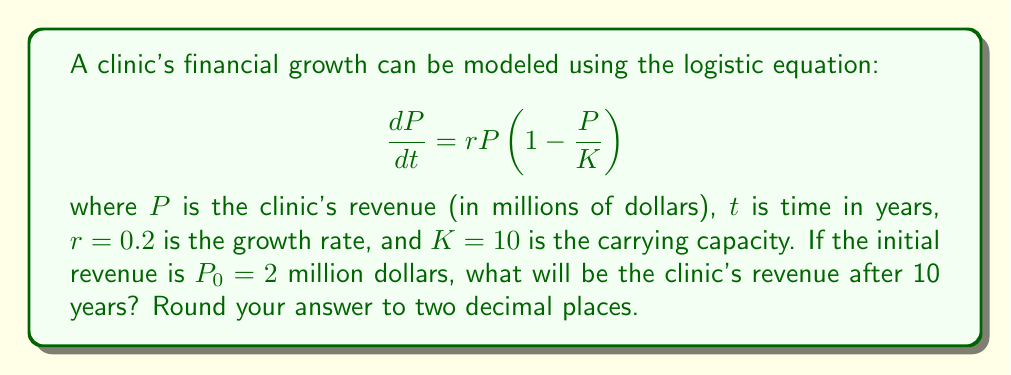Show me your answer to this math problem. To solve this problem, we need to use the solution to the logistic differential equation:

1) The general solution to the logistic equation is:

   $$P(t) = \frac{K}{1 + (\frac{K}{P_0} - 1)e^{-rt}}$$

2) We're given:
   $K = 10$ (carrying capacity)
   $r = 0.2$ (growth rate)
   $P_0 = 2$ (initial revenue)
   $t = 10$ (time in years)

3) Let's substitute these values into the equation:

   $$P(10) = \frac{10}{1 + (\frac{10}{2} - 1)e^{-0.2(10)}}$$

4) Simplify:
   $$P(10) = \frac{10}{1 + 4e^{-2}}$$

5) Calculate $e^{-2} \approx 0.1353$:
   $$P(10) = \frac{10}{1 + 4(0.1353)} = \frac{10}{1.5412}$$

6) Divide:
   $$P(10) \approx 6.49$$

7) Rounding to two decimal places:
   $$P(10) \approx 6.49$$ million dollars
Answer: $6.49 million 